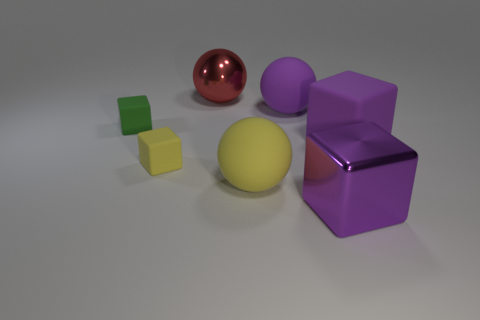Add 2 gray cubes. How many objects exist? 9 Subtract all blocks. How many objects are left? 3 Subtract all matte spheres. Subtract all red spheres. How many objects are left? 4 Add 5 large red things. How many large red things are left? 6 Add 3 big red metal objects. How many big red metal objects exist? 4 Subtract 0 blue cylinders. How many objects are left? 7 